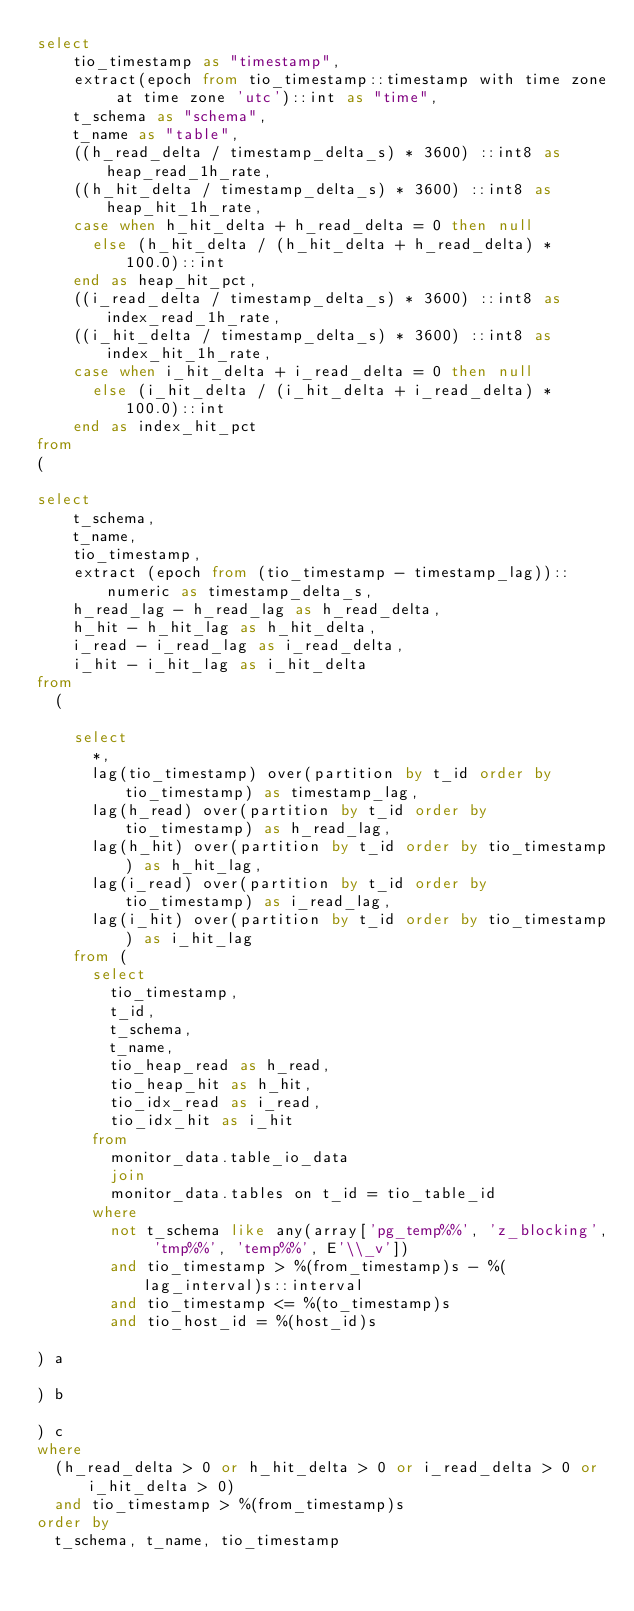Convert code to text. <code><loc_0><loc_0><loc_500><loc_500><_SQL_>select
    tio_timestamp as "timestamp",
    extract(epoch from tio_timestamp::timestamp with time zone at time zone 'utc')::int as "time",
    t_schema as "schema",
    t_name as "table",
    ((h_read_delta / timestamp_delta_s) * 3600) ::int8 as heap_read_1h_rate,
    ((h_hit_delta / timestamp_delta_s) * 3600) ::int8 as heap_hit_1h_rate,
    case when h_hit_delta + h_read_delta = 0 then null
      else (h_hit_delta / (h_hit_delta + h_read_delta) * 100.0)::int
    end as heap_hit_pct,
    ((i_read_delta / timestamp_delta_s) * 3600) ::int8 as index_read_1h_rate,
    ((i_hit_delta / timestamp_delta_s) * 3600) ::int8 as index_hit_1h_rate,
    case when i_hit_delta + i_read_delta = 0 then null
      else (i_hit_delta / (i_hit_delta + i_read_delta) * 100.0)::int
    end as index_hit_pct
from
(

select
    t_schema,
    t_name,
    tio_timestamp,
    extract (epoch from (tio_timestamp - timestamp_lag))::numeric as timestamp_delta_s,
    h_read_lag - h_read_lag as h_read_delta,
    h_hit - h_hit_lag as h_hit_delta,
    i_read - i_read_lag as i_read_delta,
    i_hit - i_hit_lag as i_hit_delta
from
  (

    select
      *,
      lag(tio_timestamp) over(partition by t_id order by tio_timestamp) as timestamp_lag,
      lag(h_read) over(partition by t_id order by tio_timestamp) as h_read_lag,
      lag(h_hit) over(partition by t_id order by tio_timestamp) as h_hit_lag,
      lag(i_read) over(partition by t_id order by tio_timestamp) as i_read_lag,
      lag(i_hit) over(partition by t_id order by tio_timestamp) as i_hit_lag
    from (
      select
        tio_timestamp,
        t_id,
        t_schema,
        t_name,
        tio_heap_read as h_read,
        tio_heap_hit as h_hit,
        tio_idx_read as i_read,
        tio_idx_hit as i_hit
      from
        monitor_data.table_io_data
        join
        monitor_data.tables on t_id = tio_table_id
      where
        not t_schema like any(array['pg_temp%%', 'z_blocking', 'tmp%%', 'temp%%', E'\\_v'])
        and tio_timestamp > %(from_timestamp)s - %(lag_interval)s::interval
        and tio_timestamp <= %(to_timestamp)s
        and tio_host_id = %(host_id)s

) a

) b

) c
where
  (h_read_delta > 0 or h_hit_delta > 0 or i_read_delta > 0 or i_hit_delta > 0)
  and tio_timestamp > %(from_timestamp)s
order by
  t_schema, t_name, tio_timestamp
</code> 